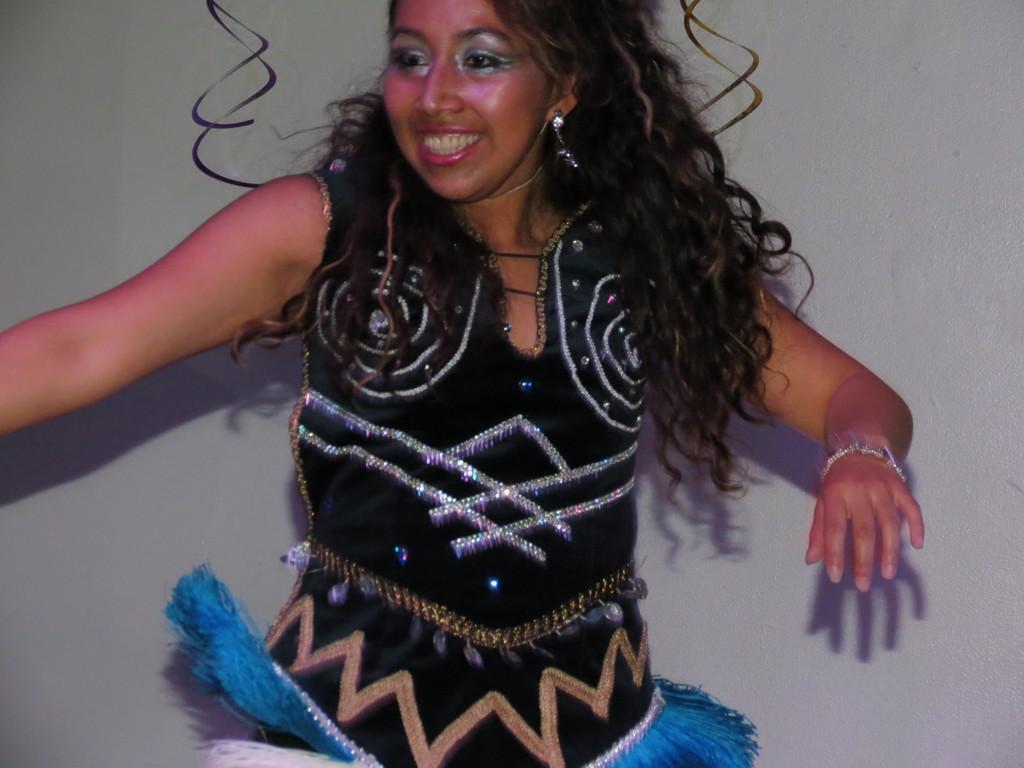Please provide a concise description of this image. This is a woman. 